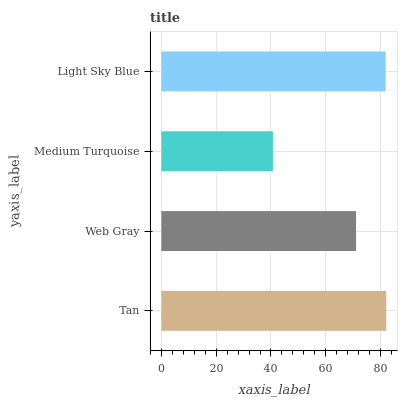Is Medium Turquoise the minimum?
Answer yes or no. Yes. Is Tan the maximum?
Answer yes or no. Yes. Is Web Gray the minimum?
Answer yes or no. No. Is Web Gray the maximum?
Answer yes or no. No. Is Tan greater than Web Gray?
Answer yes or no. Yes. Is Web Gray less than Tan?
Answer yes or no. Yes. Is Web Gray greater than Tan?
Answer yes or no. No. Is Tan less than Web Gray?
Answer yes or no. No. Is Light Sky Blue the high median?
Answer yes or no. Yes. Is Web Gray the low median?
Answer yes or no. Yes. Is Medium Turquoise the high median?
Answer yes or no. No. Is Light Sky Blue the low median?
Answer yes or no. No. 